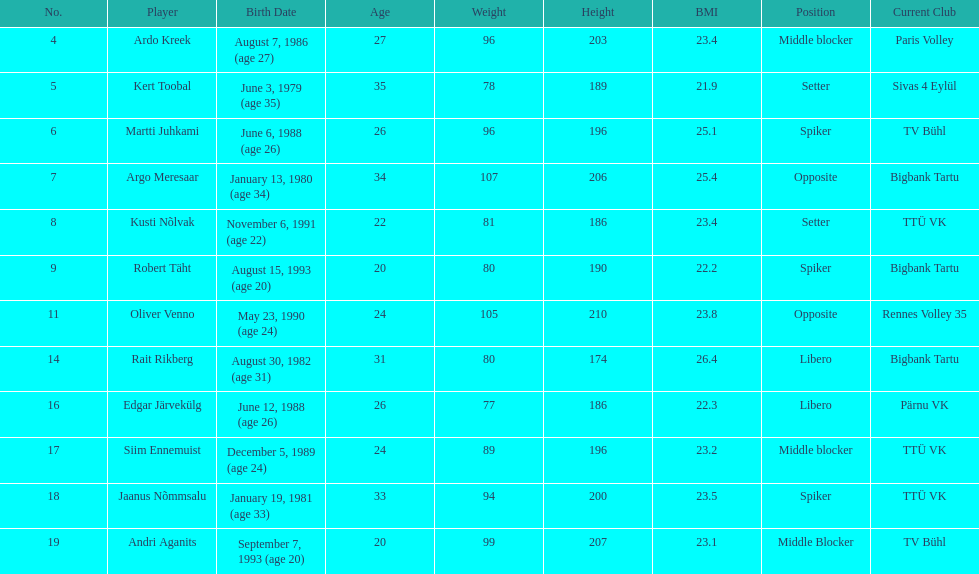How many players were born before 1988? 5. 